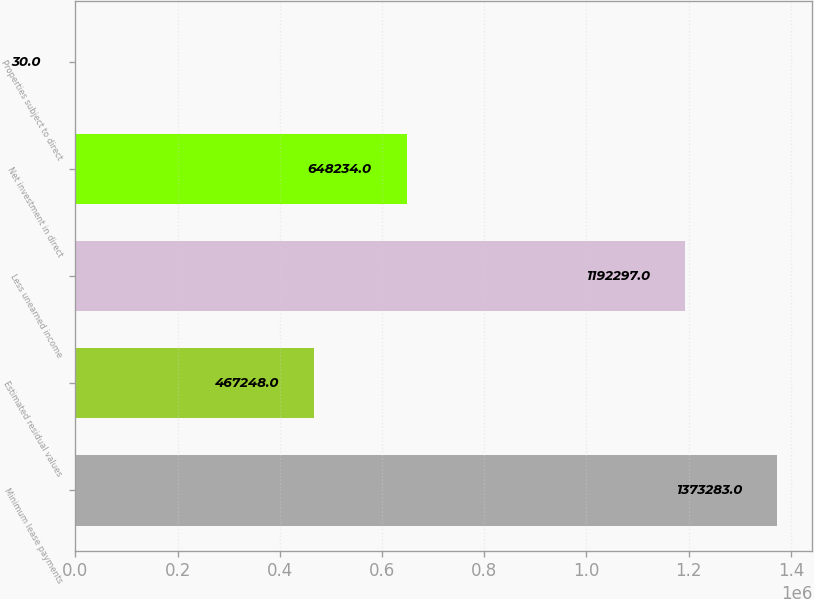Convert chart. <chart><loc_0><loc_0><loc_500><loc_500><bar_chart><fcel>Minimum lease payments<fcel>Estimated residual values<fcel>Less unearned income<fcel>Net investment in direct<fcel>Properties subject to direct<nl><fcel>1.37328e+06<fcel>467248<fcel>1.1923e+06<fcel>648234<fcel>30<nl></chart> 